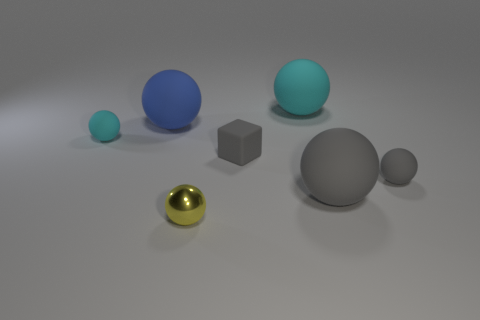The large gray object is what shape?
Provide a succinct answer. Sphere. There is a large thing that is in front of the tiny gray block; is there a matte sphere behind it?
Offer a terse response. Yes. There is a gray block that is the same size as the yellow ball; what is it made of?
Your answer should be very brief. Rubber. Are there any gray blocks that have the same size as the metallic thing?
Keep it short and to the point. Yes. What material is the small ball that is right of the large gray sphere?
Make the answer very short. Rubber. Do the sphere that is left of the large blue thing and the small yellow sphere have the same material?
Offer a terse response. No. What shape is the cyan thing that is the same size as the blue thing?
Offer a terse response. Sphere. How many other small blocks are the same color as the matte cube?
Your answer should be very brief. 0. Is the number of small cubes that are right of the tiny matte block less than the number of small cyan objects that are behind the blue matte object?
Give a very brief answer. No. There is a small yellow metal thing; are there any large cyan matte objects to the left of it?
Your answer should be very brief. No. 